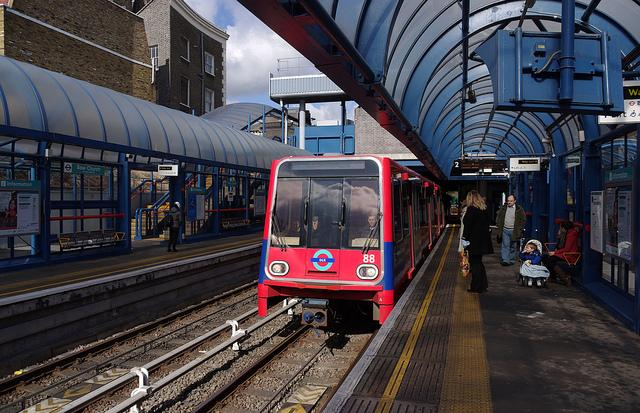Why are they all looking at the train? boarding 